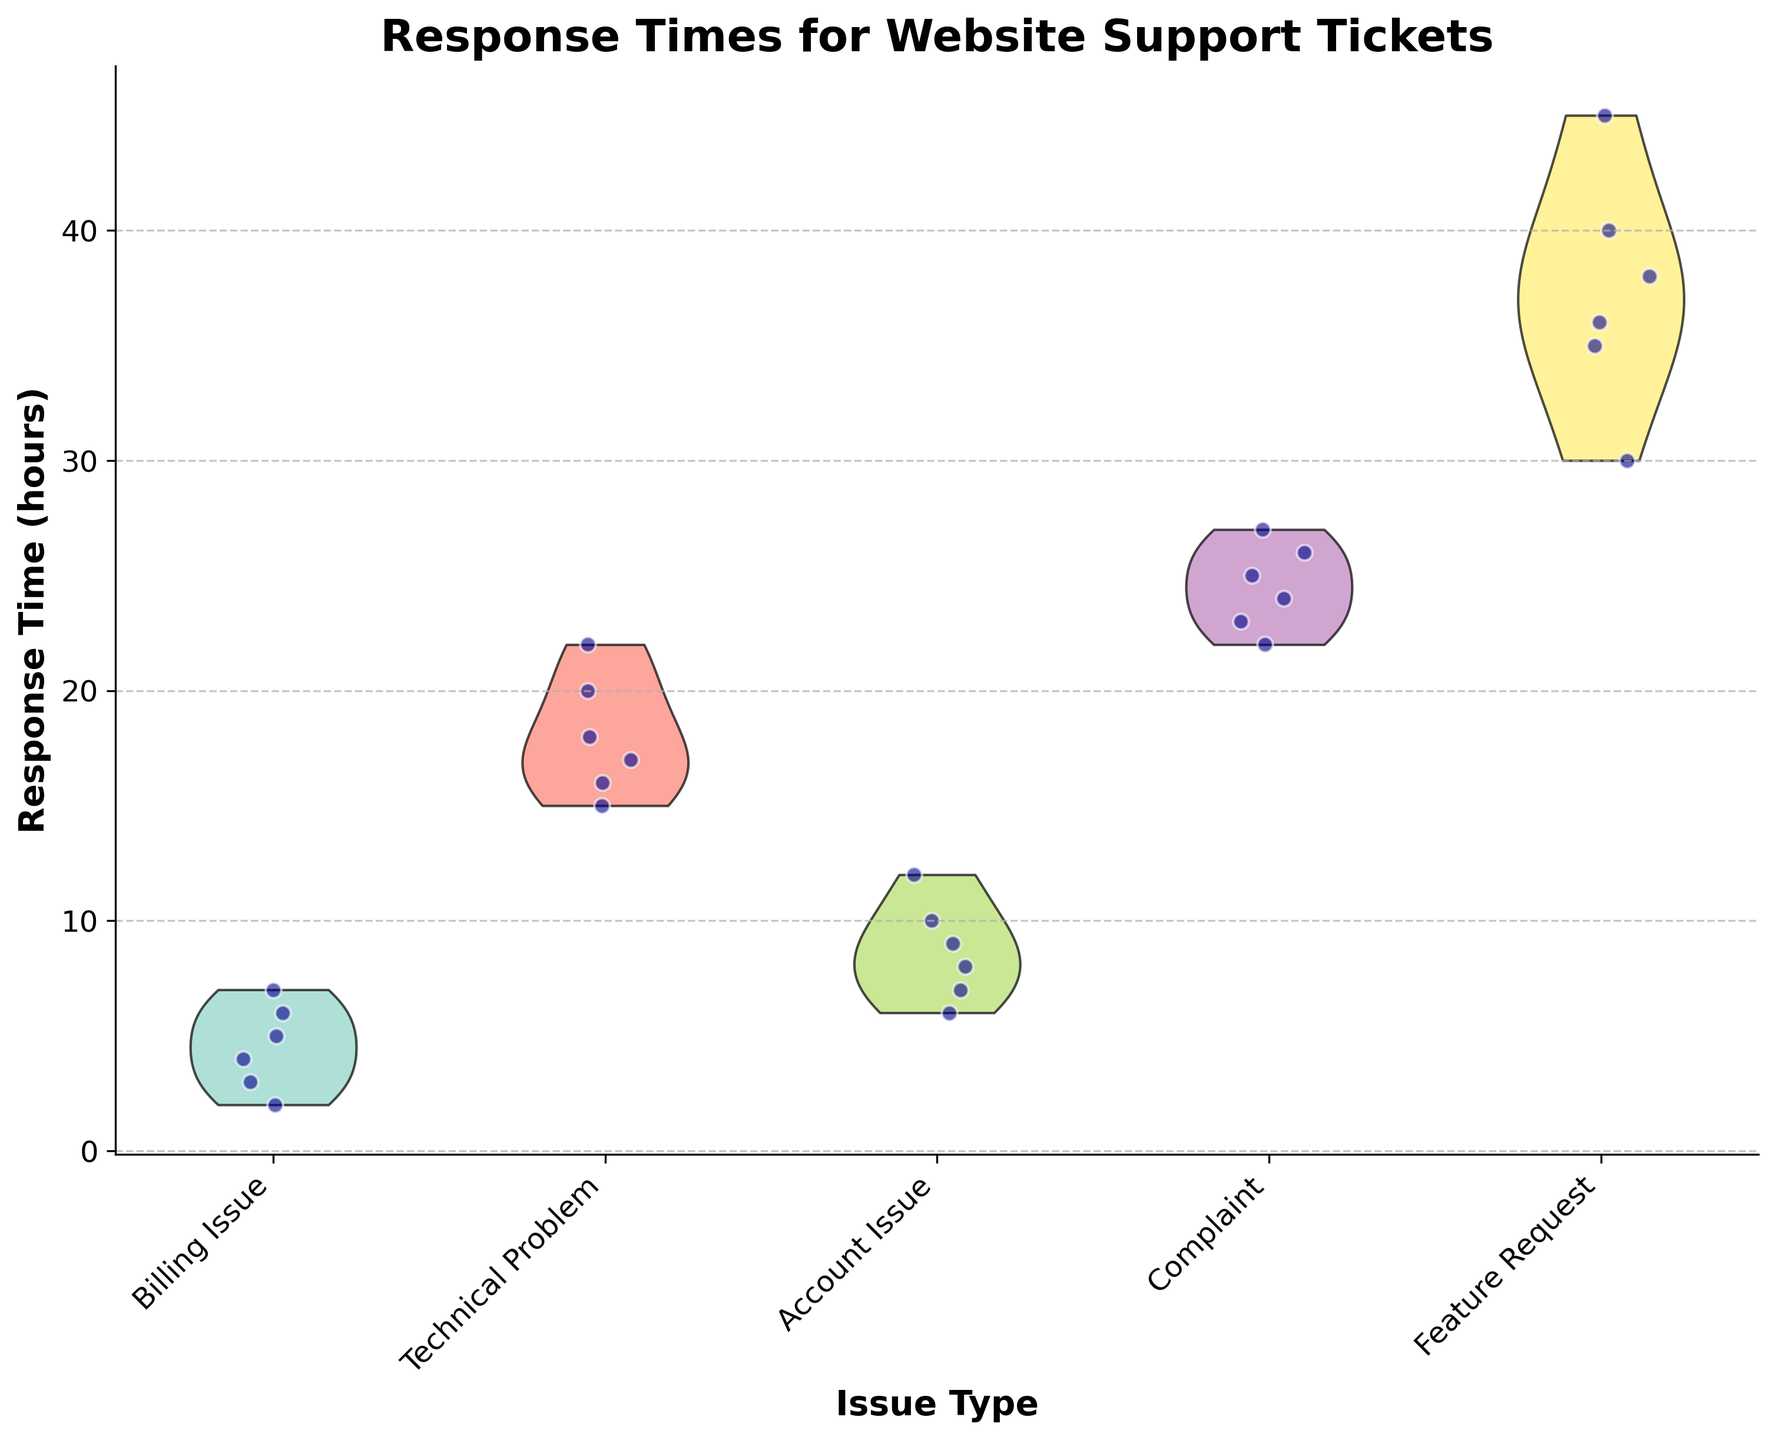What is the title of the plot? The title of the plot is usually found at the top, clearly indicating what the plot is about. In this case, it is "Response Times for Website Support Tickets".
Answer: Response Times for Website Support Tickets How many types of issues are represented in the plot? The number of different "Issue Type" categories can be determined by counting the distinct labels on the x-axis.
Answer: Five What is the range of response times for Billing Issues? To determine the range, identify the minimum and maximum response times within the jittered points for Billing Issue. These appear near the first x-axis label.
Answer: 2 to 7 hours Which issue type has the highest median response time? To find the highest median response time, visually estimate the central tendency of the violin plots. The largest value in terms of response time is observed for Feature Requests.
Answer: Feature Request Compare the average response time for Technical Problems and Account Issues. To compare averages, visually estimate the center of the jittered points in each violin plot and compare them. Technical Problems appear to have higher average response times than Account Issues.
Answer: Technical Problems have a higher average response time What is the shape of the distribution for Complaint response times? The shape of the violin plot for Complaints can indicate distribution characteristics such as skewness, multimodality, etc. The Complaint distribution is wide with no distinct peak suggesting a fairly uniform distribution between 22 to 27 hours.
Answer: Uniform Which issue type has the most variability in response times? Variability can be assessed by looking at the spread of the violin plots and the spread of jittered points. The Feature Request category has the widest spread, indicating the most variability.
Answer: Feature Request Are there any outliers in the Billing Issue category? Outliers would be points far removed from the main body of the data, often visibly isolated from most points in the jittered scatter or edges of the violin plot. There are no significant outliers for Billing Issues since all points lie close to the main distribution.
Answer: No How does the response time for Complaints compare to Technical Problems? Compare the central tendency and spread of the jittered points and violin plots for Complaints and Technical Problems. Complaints have generally higher response times than Technical Problems.
Answer: Complaints have higher response times 